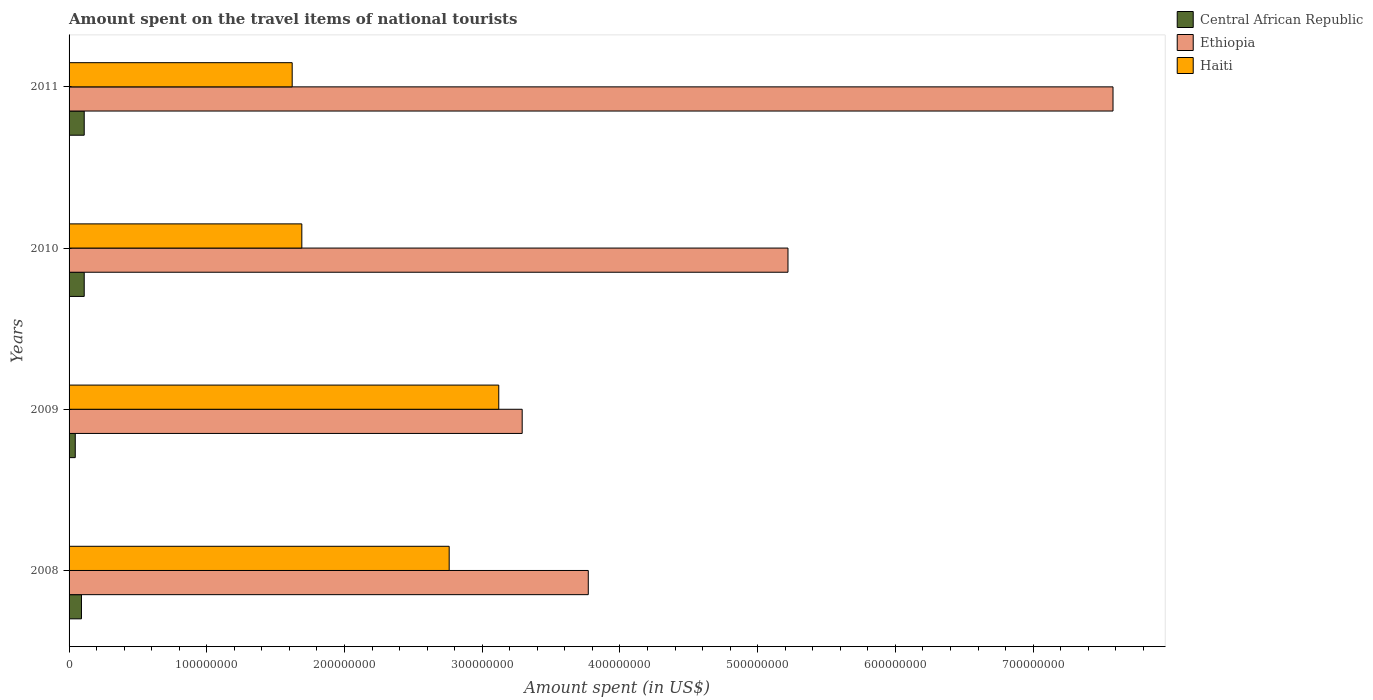Are the number of bars per tick equal to the number of legend labels?
Provide a short and direct response. Yes. Are the number of bars on each tick of the Y-axis equal?
Ensure brevity in your answer.  Yes. How many bars are there on the 3rd tick from the bottom?
Ensure brevity in your answer.  3. What is the label of the 4th group of bars from the top?
Your answer should be very brief. 2008. What is the amount spent on the travel items of national tourists in Central African Republic in 2009?
Give a very brief answer. 4.50e+06. Across all years, what is the maximum amount spent on the travel items of national tourists in Haiti?
Keep it short and to the point. 3.12e+08. Across all years, what is the minimum amount spent on the travel items of national tourists in Central African Republic?
Your answer should be compact. 4.50e+06. What is the total amount spent on the travel items of national tourists in Central African Republic in the graph?
Make the answer very short. 3.55e+07. What is the difference between the amount spent on the travel items of national tourists in Haiti in 2009 and that in 2010?
Provide a succinct answer. 1.43e+08. What is the difference between the amount spent on the travel items of national tourists in Ethiopia in 2010 and the amount spent on the travel items of national tourists in Central African Republic in 2008?
Provide a short and direct response. 5.13e+08. What is the average amount spent on the travel items of national tourists in Ethiopia per year?
Give a very brief answer. 4.96e+08. In the year 2008, what is the difference between the amount spent on the travel items of national tourists in Ethiopia and amount spent on the travel items of national tourists in Central African Republic?
Give a very brief answer. 3.68e+08. In how many years, is the amount spent on the travel items of national tourists in Central African Republic greater than 520000000 US$?
Keep it short and to the point. 0. What is the ratio of the amount spent on the travel items of national tourists in Ethiopia in 2009 to that in 2010?
Ensure brevity in your answer.  0.63. Is the amount spent on the travel items of national tourists in Haiti in 2008 less than that in 2009?
Give a very brief answer. Yes. Is the difference between the amount spent on the travel items of national tourists in Ethiopia in 2008 and 2009 greater than the difference between the amount spent on the travel items of national tourists in Central African Republic in 2008 and 2009?
Give a very brief answer. Yes. What is the difference between the highest and the second highest amount spent on the travel items of national tourists in Haiti?
Offer a terse response. 3.60e+07. What is the difference between the highest and the lowest amount spent on the travel items of national tourists in Central African Republic?
Provide a succinct answer. 6.50e+06. What does the 3rd bar from the top in 2010 represents?
Offer a very short reply. Central African Republic. What does the 1st bar from the bottom in 2009 represents?
Your answer should be very brief. Central African Republic. How many years are there in the graph?
Keep it short and to the point. 4. What is the difference between two consecutive major ticks on the X-axis?
Provide a succinct answer. 1.00e+08. Are the values on the major ticks of X-axis written in scientific E-notation?
Offer a very short reply. No. Where does the legend appear in the graph?
Your answer should be very brief. Top right. How many legend labels are there?
Ensure brevity in your answer.  3. How are the legend labels stacked?
Provide a succinct answer. Vertical. What is the title of the graph?
Give a very brief answer. Amount spent on the travel items of national tourists. Does "Estonia" appear as one of the legend labels in the graph?
Your response must be concise. No. What is the label or title of the X-axis?
Offer a very short reply. Amount spent (in US$). What is the label or title of the Y-axis?
Provide a succinct answer. Years. What is the Amount spent (in US$) in Central African Republic in 2008?
Give a very brief answer. 9.00e+06. What is the Amount spent (in US$) in Ethiopia in 2008?
Your response must be concise. 3.77e+08. What is the Amount spent (in US$) in Haiti in 2008?
Provide a succinct answer. 2.76e+08. What is the Amount spent (in US$) in Central African Republic in 2009?
Provide a short and direct response. 4.50e+06. What is the Amount spent (in US$) in Ethiopia in 2009?
Provide a succinct answer. 3.29e+08. What is the Amount spent (in US$) in Haiti in 2009?
Give a very brief answer. 3.12e+08. What is the Amount spent (in US$) of Central African Republic in 2010?
Your answer should be compact. 1.10e+07. What is the Amount spent (in US$) in Ethiopia in 2010?
Your answer should be compact. 5.22e+08. What is the Amount spent (in US$) of Haiti in 2010?
Your answer should be very brief. 1.69e+08. What is the Amount spent (in US$) of Central African Republic in 2011?
Your answer should be very brief. 1.10e+07. What is the Amount spent (in US$) in Ethiopia in 2011?
Ensure brevity in your answer.  7.58e+08. What is the Amount spent (in US$) in Haiti in 2011?
Your response must be concise. 1.62e+08. Across all years, what is the maximum Amount spent (in US$) of Central African Republic?
Give a very brief answer. 1.10e+07. Across all years, what is the maximum Amount spent (in US$) of Ethiopia?
Your answer should be very brief. 7.58e+08. Across all years, what is the maximum Amount spent (in US$) of Haiti?
Offer a terse response. 3.12e+08. Across all years, what is the minimum Amount spent (in US$) in Central African Republic?
Give a very brief answer. 4.50e+06. Across all years, what is the minimum Amount spent (in US$) in Ethiopia?
Offer a very short reply. 3.29e+08. Across all years, what is the minimum Amount spent (in US$) of Haiti?
Your answer should be compact. 1.62e+08. What is the total Amount spent (in US$) of Central African Republic in the graph?
Your response must be concise. 3.55e+07. What is the total Amount spent (in US$) in Ethiopia in the graph?
Provide a short and direct response. 1.99e+09. What is the total Amount spent (in US$) in Haiti in the graph?
Offer a terse response. 9.19e+08. What is the difference between the Amount spent (in US$) in Central African Republic in 2008 and that in 2009?
Give a very brief answer. 4.50e+06. What is the difference between the Amount spent (in US$) of Ethiopia in 2008 and that in 2009?
Your response must be concise. 4.80e+07. What is the difference between the Amount spent (in US$) in Haiti in 2008 and that in 2009?
Your answer should be very brief. -3.60e+07. What is the difference between the Amount spent (in US$) of Central African Republic in 2008 and that in 2010?
Keep it short and to the point. -2.00e+06. What is the difference between the Amount spent (in US$) of Ethiopia in 2008 and that in 2010?
Make the answer very short. -1.45e+08. What is the difference between the Amount spent (in US$) in Haiti in 2008 and that in 2010?
Your response must be concise. 1.07e+08. What is the difference between the Amount spent (in US$) in Central African Republic in 2008 and that in 2011?
Your response must be concise. -2.00e+06. What is the difference between the Amount spent (in US$) of Ethiopia in 2008 and that in 2011?
Make the answer very short. -3.81e+08. What is the difference between the Amount spent (in US$) in Haiti in 2008 and that in 2011?
Keep it short and to the point. 1.14e+08. What is the difference between the Amount spent (in US$) of Central African Republic in 2009 and that in 2010?
Make the answer very short. -6.50e+06. What is the difference between the Amount spent (in US$) in Ethiopia in 2009 and that in 2010?
Your response must be concise. -1.93e+08. What is the difference between the Amount spent (in US$) in Haiti in 2009 and that in 2010?
Give a very brief answer. 1.43e+08. What is the difference between the Amount spent (in US$) of Central African Republic in 2009 and that in 2011?
Keep it short and to the point. -6.50e+06. What is the difference between the Amount spent (in US$) in Ethiopia in 2009 and that in 2011?
Ensure brevity in your answer.  -4.29e+08. What is the difference between the Amount spent (in US$) of Haiti in 2009 and that in 2011?
Provide a succinct answer. 1.50e+08. What is the difference between the Amount spent (in US$) in Ethiopia in 2010 and that in 2011?
Ensure brevity in your answer.  -2.36e+08. What is the difference between the Amount spent (in US$) of Haiti in 2010 and that in 2011?
Your answer should be compact. 7.00e+06. What is the difference between the Amount spent (in US$) in Central African Republic in 2008 and the Amount spent (in US$) in Ethiopia in 2009?
Make the answer very short. -3.20e+08. What is the difference between the Amount spent (in US$) in Central African Republic in 2008 and the Amount spent (in US$) in Haiti in 2009?
Ensure brevity in your answer.  -3.03e+08. What is the difference between the Amount spent (in US$) in Ethiopia in 2008 and the Amount spent (in US$) in Haiti in 2009?
Provide a short and direct response. 6.50e+07. What is the difference between the Amount spent (in US$) in Central African Republic in 2008 and the Amount spent (in US$) in Ethiopia in 2010?
Provide a succinct answer. -5.13e+08. What is the difference between the Amount spent (in US$) in Central African Republic in 2008 and the Amount spent (in US$) in Haiti in 2010?
Your answer should be very brief. -1.60e+08. What is the difference between the Amount spent (in US$) in Ethiopia in 2008 and the Amount spent (in US$) in Haiti in 2010?
Give a very brief answer. 2.08e+08. What is the difference between the Amount spent (in US$) of Central African Republic in 2008 and the Amount spent (in US$) of Ethiopia in 2011?
Make the answer very short. -7.49e+08. What is the difference between the Amount spent (in US$) of Central African Republic in 2008 and the Amount spent (in US$) of Haiti in 2011?
Give a very brief answer. -1.53e+08. What is the difference between the Amount spent (in US$) in Ethiopia in 2008 and the Amount spent (in US$) in Haiti in 2011?
Give a very brief answer. 2.15e+08. What is the difference between the Amount spent (in US$) of Central African Republic in 2009 and the Amount spent (in US$) of Ethiopia in 2010?
Ensure brevity in your answer.  -5.18e+08. What is the difference between the Amount spent (in US$) in Central African Republic in 2009 and the Amount spent (in US$) in Haiti in 2010?
Provide a succinct answer. -1.64e+08. What is the difference between the Amount spent (in US$) of Ethiopia in 2009 and the Amount spent (in US$) of Haiti in 2010?
Provide a succinct answer. 1.60e+08. What is the difference between the Amount spent (in US$) of Central African Republic in 2009 and the Amount spent (in US$) of Ethiopia in 2011?
Ensure brevity in your answer.  -7.54e+08. What is the difference between the Amount spent (in US$) of Central African Republic in 2009 and the Amount spent (in US$) of Haiti in 2011?
Your answer should be compact. -1.58e+08. What is the difference between the Amount spent (in US$) in Ethiopia in 2009 and the Amount spent (in US$) in Haiti in 2011?
Give a very brief answer. 1.67e+08. What is the difference between the Amount spent (in US$) in Central African Republic in 2010 and the Amount spent (in US$) in Ethiopia in 2011?
Your answer should be compact. -7.47e+08. What is the difference between the Amount spent (in US$) of Central African Republic in 2010 and the Amount spent (in US$) of Haiti in 2011?
Make the answer very short. -1.51e+08. What is the difference between the Amount spent (in US$) in Ethiopia in 2010 and the Amount spent (in US$) in Haiti in 2011?
Make the answer very short. 3.60e+08. What is the average Amount spent (in US$) in Central African Republic per year?
Provide a short and direct response. 8.88e+06. What is the average Amount spent (in US$) in Ethiopia per year?
Provide a succinct answer. 4.96e+08. What is the average Amount spent (in US$) of Haiti per year?
Provide a short and direct response. 2.30e+08. In the year 2008, what is the difference between the Amount spent (in US$) of Central African Republic and Amount spent (in US$) of Ethiopia?
Your answer should be compact. -3.68e+08. In the year 2008, what is the difference between the Amount spent (in US$) in Central African Republic and Amount spent (in US$) in Haiti?
Give a very brief answer. -2.67e+08. In the year 2008, what is the difference between the Amount spent (in US$) in Ethiopia and Amount spent (in US$) in Haiti?
Offer a very short reply. 1.01e+08. In the year 2009, what is the difference between the Amount spent (in US$) in Central African Republic and Amount spent (in US$) in Ethiopia?
Offer a very short reply. -3.24e+08. In the year 2009, what is the difference between the Amount spent (in US$) of Central African Republic and Amount spent (in US$) of Haiti?
Your answer should be very brief. -3.08e+08. In the year 2009, what is the difference between the Amount spent (in US$) of Ethiopia and Amount spent (in US$) of Haiti?
Keep it short and to the point. 1.70e+07. In the year 2010, what is the difference between the Amount spent (in US$) in Central African Republic and Amount spent (in US$) in Ethiopia?
Your answer should be compact. -5.11e+08. In the year 2010, what is the difference between the Amount spent (in US$) of Central African Republic and Amount spent (in US$) of Haiti?
Provide a succinct answer. -1.58e+08. In the year 2010, what is the difference between the Amount spent (in US$) in Ethiopia and Amount spent (in US$) in Haiti?
Your response must be concise. 3.53e+08. In the year 2011, what is the difference between the Amount spent (in US$) in Central African Republic and Amount spent (in US$) in Ethiopia?
Keep it short and to the point. -7.47e+08. In the year 2011, what is the difference between the Amount spent (in US$) in Central African Republic and Amount spent (in US$) in Haiti?
Provide a succinct answer. -1.51e+08. In the year 2011, what is the difference between the Amount spent (in US$) of Ethiopia and Amount spent (in US$) of Haiti?
Ensure brevity in your answer.  5.96e+08. What is the ratio of the Amount spent (in US$) in Central African Republic in 2008 to that in 2009?
Offer a terse response. 2. What is the ratio of the Amount spent (in US$) of Ethiopia in 2008 to that in 2009?
Your answer should be compact. 1.15. What is the ratio of the Amount spent (in US$) in Haiti in 2008 to that in 2009?
Offer a very short reply. 0.88. What is the ratio of the Amount spent (in US$) of Central African Republic in 2008 to that in 2010?
Make the answer very short. 0.82. What is the ratio of the Amount spent (in US$) of Ethiopia in 2008 to that in 2010?
Your answer should be very brief. 0.72. What is the ratio of the Amount spent (in US$) of Haiti in 2008 to that in 2010?
Your answer should be compact. 1.63. What is the ratio of the Amount spent (in US$) in Central African Republic in 2008 to that in 2011?
Your answer should be compact. 0.82. What is the ratio of the Amount spent (in US$) in Ethiopia in 2008 to that in 2011?
Your answer should be very brief. 0.5. What is the ratio of the Amount spent (in US$) of Haiti in 2008 to that in 2011?
Your response must be concise. 1.7. What is the ratio of the Amount spent (in US$) of Central African Republic in 2009 to that in 2010?
Provide a succinct answer. 0.41. What is the ratio of the Amount spent (in US$) of Ethiopia in 2009 to that in 2010?
Provide a short and direct response. 0.63. What is the ratio of the Amount spent (in US$) in Haiti in 2009 to that in 2010?
Provide a short and direct response. 1.85. What is the ratio of the Amount spent (in US$) in Central African Republic in 2009 to that in 2011?
Provide a short and direct response. 0.41. What is the ratio of the Amount spent (in US$) in Ethiopia in 2009 to that in 2011?
Keep it short and to the point. 0.43. What is the ratio of the Amount spent (in US$) of Haiti in 2009 to that in 2011?
Your answer should be compact. 1.93. What is the ratio of the Amount spent (in US$) of Central African Republic in 2010 to that in 2011?
Keep it short and to the point. 1. What is the ratio of the Amount spent (in US$) of Ethiopia in 2010 to that in 2011?
Provide a succinct answer. 0.69. What is the ratio of the Amount spent (in US$) of Haiti in 2010 to that in 2011?
Provide a short and direct response. 1.04. What is the difference between the highest and the second highest Amount spent (in US$) in Central African Republic?
Your answer should be very brief. 0. What is the difference between the highest and the second highest Amount spent (in US$) in Ethiopia?
Your response must be concise. 2.36e+08. What is the difference between the highest and the second highest Amount spent (in US$) of Haiti?
Offer a very short reply. 3.60e+07. What is the difference between the highest and the lowest Amount spent (in US$) in Central African Republic?
Ensure brevity in your answer.  6.50e+06. What is the difference between the highest and the lowest Amount spent (in US$) in Ethiopia?
Provide a succinct answer. 4.29e+08. What is the difference between the highest and the lowest Amount spent (in US$) in Haiti?
Offer a very short reply. 1.50e+08. 